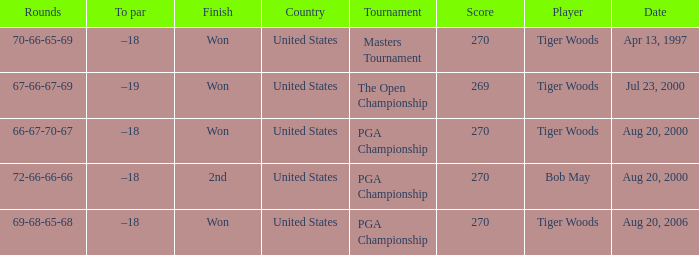What players finished 2nd? Bob May. 